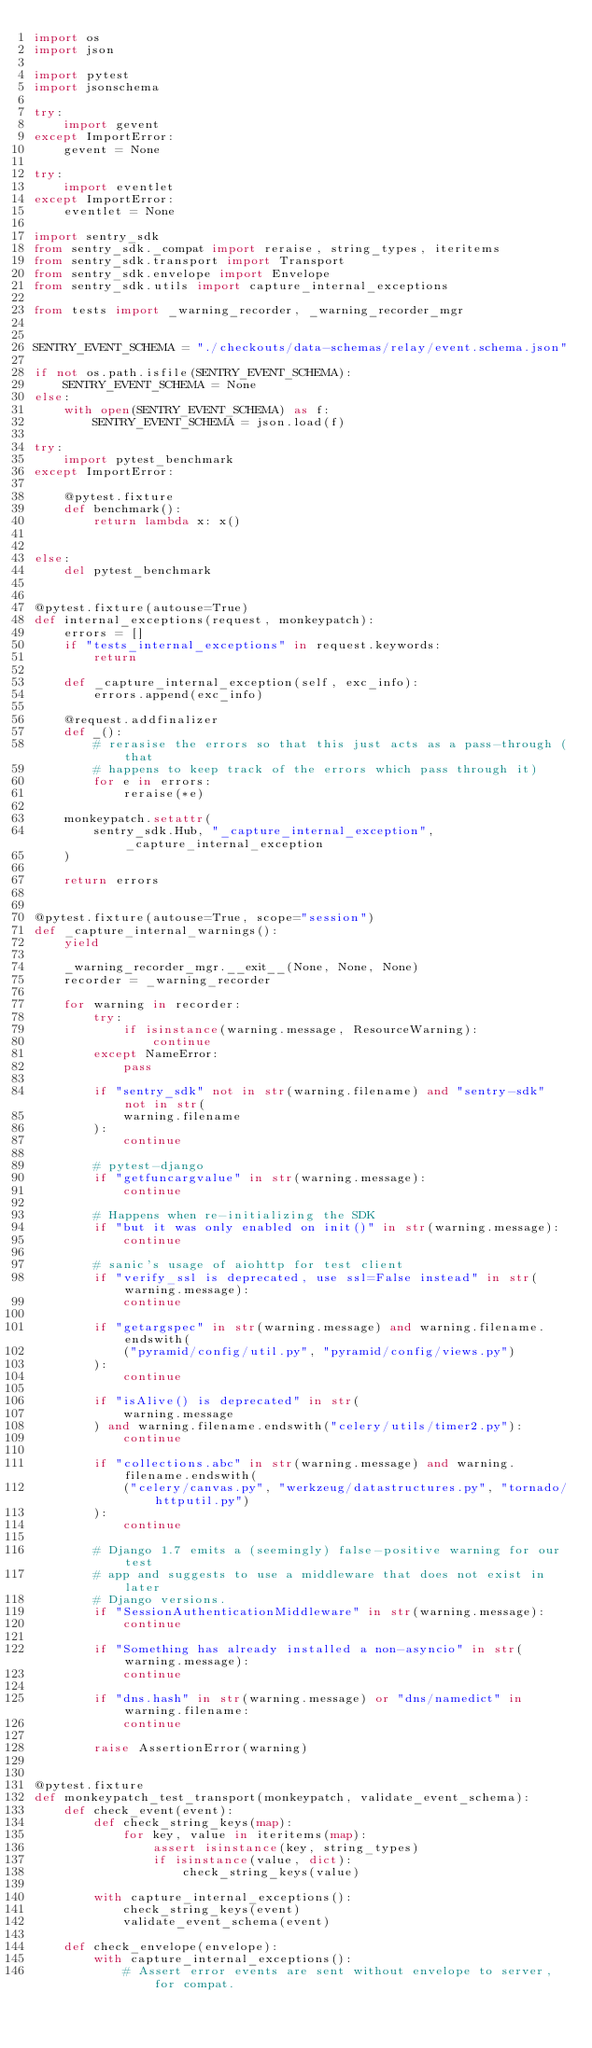Convert code to text. <code><loc_0><loc_0><loc_500><loc_500><_Python_>import os
import json

import pytest
import jsonschema

try:
    import gevent
except ImportError:
    gevent = None

try:
    import eventlet
except ImportError:
    eventlet = None

import sentry_sdk
from sentry_sdk._compat import reraise, string_types, iteritems
from sentry_sdk.transport import Transport
from sentry_sdk.envelope import Envelope
from sentry_sdk.utils import capture_internal_exceptions

from tests import _warning_recorder, _warning_recorder_mgr


SENTRY_EVENT_SCHEMA = "./checkouts/data-schemas/relay/event.schema.json"

if not os.path.isfile(SENTRY_EVENT_SCHEMA):
    SENTRY_EVENT_SCHEMA = None
else:
    with open(SENTRY_EVENT_SCHEMA) as f:
        SENTRY_EVENT_SCHEMA = json.load(f)

try:
    import pytest_benchmark
except ImportError:

    @pytest.fixture
    def benchmark():
        return lambda x: x()


else:
    del pytest_benchmark


@pytest.fixture(autouse=True)
def internal_exceptions(request, monkeypatch):
    errors = []
    if "tests_internal_exceptions" in request.keywords:
        return

    def _capture_internal_exception(self, exc_info):
        errors.append(exc_info)

    @request.addfinalizer
    def _():
        # rerasise the errors so that this just acts as a pass-through (that
        # happens to keep track of the errors which pass through it)
        for e in errors:
            reraise(*e)

    monkeypatch.setattr(
        sentry_sdk.Hub, "_capture_internal_exception", _capture_internal_exception
    )

    return errors


@pytest.fixture(autouse=True, scope="session")
def _capture_internal_warnings():
    yield

    _warning_recorder_mgr.__exit__(None, None, None)
    recorder = _warning_recorder

    for warning in recorder:
        try:
            if isinstance(warning.message, ResourceWarning):
                continue
        except NameError:
            pass

        if "sentry_sdk" not in str(warning.filename) and "sentry-sdk" not in str(
            warning.filename
        ):
            continue

        # pytest-django
        if "getfuncargvalue" in str(warning.message):
            continue

        # Happens when re-initializing the SDK
        if "but it was only enabled on init()" in str(warning.message):
            continue

        # sanic's usage of aiohttp for test client
        if "verify_ssl is deprecated, use ssl=False instead" in str(warning.message):
            continue

        if "getargspec" in str(warning.message) and warning.filename.endswith(
            ("pyramid/config/util.py", "pyramid/config/views.py")
        ):
            continue

        if "isAlive() is deprecated" in str(
            warning.message
        ) and warning.filename.endswith("celery/utils/timer2.py"):
            continue

        if "collections.abc" in str(warning.message) and warning.filename.endswith(
            ("celery/canvas.py", "werkzeug/datastructures.py", "tornado/httputil.py")
        ):
            continue

        # Django 1.7 emits a (seemingly) false-positive warning for our test
        # app and suggests to use a middleware that does not exist in later
        # Django versions.
        if "SessionAuthenticationMiddleware" in str(warning.message):
            continue

        if "Something has already installed a non-asyncio" in str(warning.message):
            continue

        if "dns.hash" in str(warning.message) or "dns/namedict" in warning.filename:
            continue

        raise AssertionError(warning)


@pytest.fixture
def monkeypatch_test_transport(monkeypatch, validate_event_schema):
    def check_event(event):
        def check_string_keys(map):
            for key, value in iteritems(map):
                assert isinstance(key, string_types)
                if isinstance(value, dict):
                    check_string_keys(value)

        with capture_internal_exceptions():
            check_string_keys(event)
            validate_event_schema(event)

    def check_envelope(envelope):
        with capture_internal_exceptions():
            # Assert error events are sent without envelope to server, for compat.</code> 